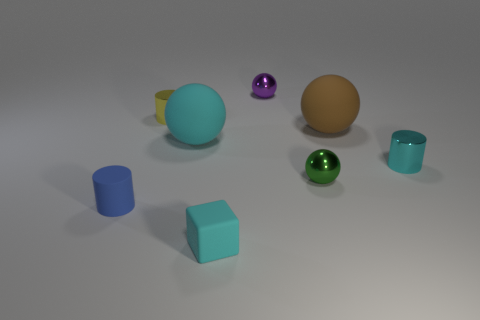There is a metal thing that is the same color as the small cube; what is its shape?
Provide a short and direct response. Cylinder. Is the sphere in front of the tiny cyan shiny object made of the same material as the blue object that is in front of the purple metal ball?
Provide a succinct answer. No. There is a cyan object that is both behind the small cyan rubber thing and left of the purple metal thing; what is it made of?
Your answer should be very brief. Rubber. Do the brown thing and the small thing that is right of the green sphere have the same shape?
Make the answer very short. No. There is a cylinder on the left side of the tiny shiny cylinder to the left of the tiny cyan thing on the right side of the brown rubber object; what is it made of?
Offer a very short reply. Rubber. What number of other things are the same size as the brown sphere?
Give a very brief answer. 1. Does the matte cylinder have the same color as the rubber cube?
Your response must be concise. No. What number of green shiny things are on the left side of the small cyan object that is behind the sphere in front of the large cyan sphere?
Provide a succinct answer. 1. What is the material of the cylinder that is to the right of the tiny cyan thing that is in front of the cyan cylinder?
Provide a short and direct response. Metal. Is there a big brown matte thing of the same shape as the tiny cyan metal thing?
Provide a succinct answer. No. 